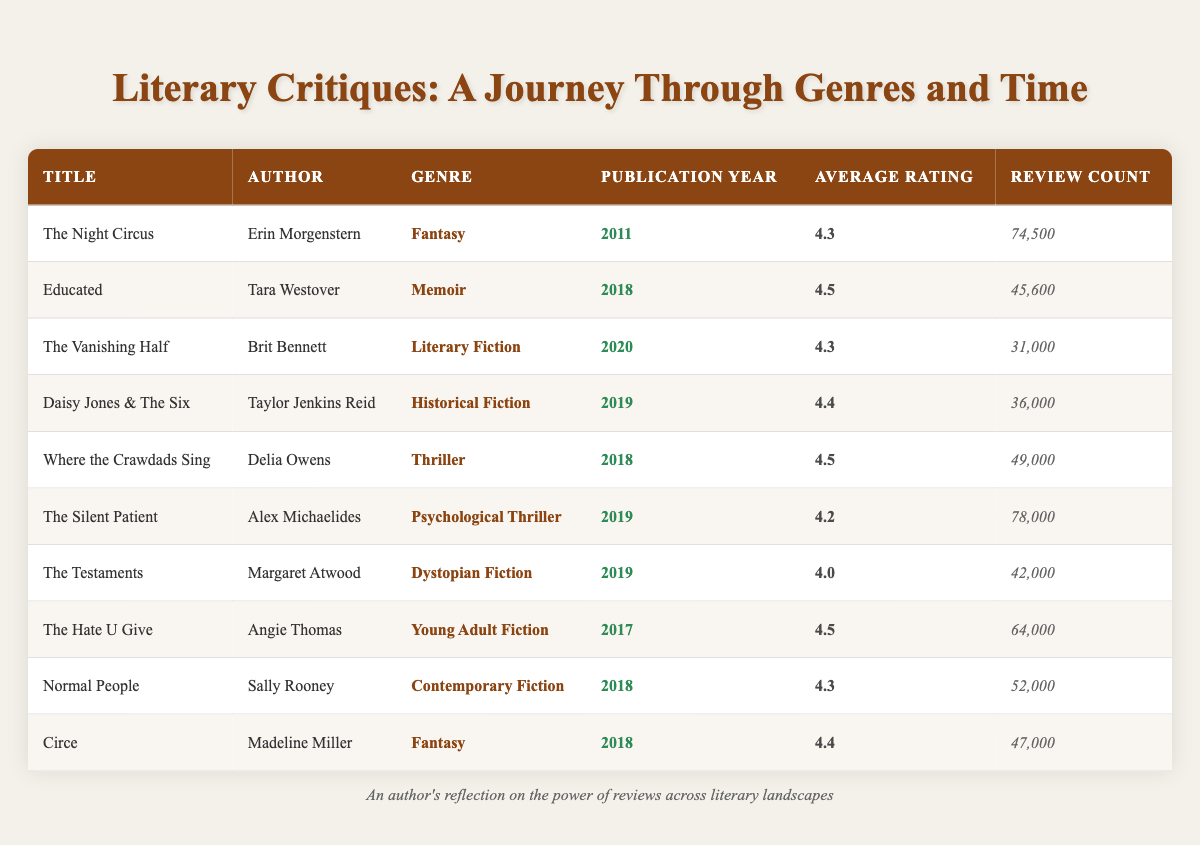What is the highest average rating among the listed books? The highest average rating is found by looking at the "Average Rating" column. The entries are 4.3, 4.5, 4.3, 4.4, 4.5, 4.2, 4.0, 4.5, 4.3, and 4.4. The maximum value among these is 4.5, which corresponds to the books "Educated," "Where the Crawdads Sing," and "The Hate U Give."
Answer: 4.5 How many reviews did "The Silent Patient" receive? This can be found in the "Review Count" column for "The Silent Patient." Looking at that row, "The Silent Patient" has a review count of 78,000.
Answer: 78,000 Is "Daisy Jones & The Six" a memoir? Looking at the genre of "Daisy Jones & The Six," it is categorized as "Historical Fiction," not memoir.
Answer: No Which genre has the most books released in 2018? To determine this, we must examine the entries for the publication year 2018. The genres for that year are Memoir (1), Thriller (1), Young Adult Fiction (1), Contemporary Fiction (1), and Fantasy (1). Each genre only has one book from 2018, so there is no singular genre with the most books.
Answer: None What is the average review count for books published in 2019? First, identify the review counts for the books published in 2019: "Daisy Jones & The Six" has 36,000, "The Silent Patient" has 78,000, "The Testaments" has 42,000. Sum these values: (36,000 + 78,000 + 42,000 = 156,000). Then divide by the number of books (3): 156,000 / 3 = 52,000.
Answer: 52,000 How many more reviews does "Where the Crawdads Sing" have compared to "Circe"? The review count for "Where the Crawdads Sing" is 49,000, and for "Circe," it is 47,000. To find the difference, subtract the review count of "Circe" from that of "Where the Crawdads Sing": 49,000 - 47,000 = 2,000.
Answer: 2,000 Which book has the lowest average rating, and what is that rating? To identify this, we check the "Average Rating" column and find the lowest value. The average ratings are 4.3, 4.5, 4.3, 4.4, 4.5, 4.2, 4.0, 4.5, 4.3, and 4.4. The lowest is 4.0, which belongs to "The Testaments."
Answer: The Testaments, 4.0 Are there any books in the table with an average rating above 4.5? By checking the "Average Rating" column, we can see if any entries exceed 4.5. The ratings present are 4.3, 4.5, 4.3, 4.4, 4.5, 4.2, 4.0, 4.5, 4.3, and 4.4, so there are no ratings above 4.5.
Answer: No 